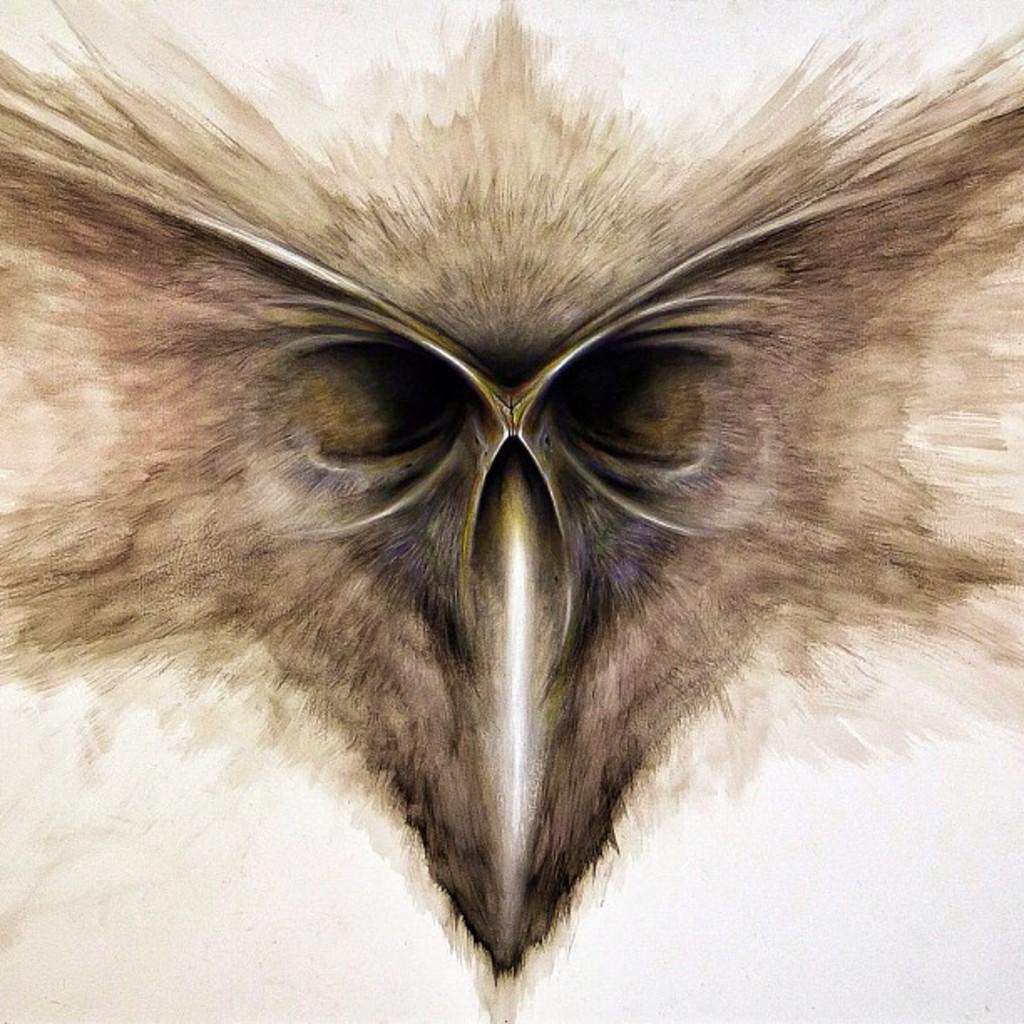Describe this image in one or two sentences. In this image we can see bird's eyes. 